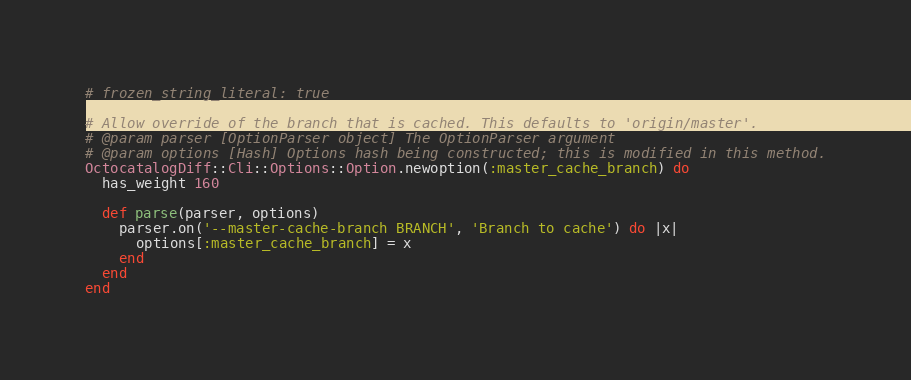Convert code to text. <code><loc_0><loc_0><loc_500><loc_500><_Ruby_># frozen_string_literal: true

# Allow override of the branch that is cached. This defaults to 'origin/master'.
# @param parser [OptionParser object] The OptionParser argument
# @param options [Hash] Options hash being constructed; this is modified in this method.
OctocatalogDiff::Cli::Options::Option.newoption(:master_cache_branch) do
  has_weight 160

  def parse(parser, options)
    parser.on('--master-cache-branch BRANCH', 'Branch to cache') do |x|
      options[:master_cache_branch] = x
    end
  end
end
</code> 